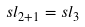<formula> <loc_0><loc_0><loc_500><loc_500>s l _ { 2 + 1 } = s l _ { 3 }</formula> 